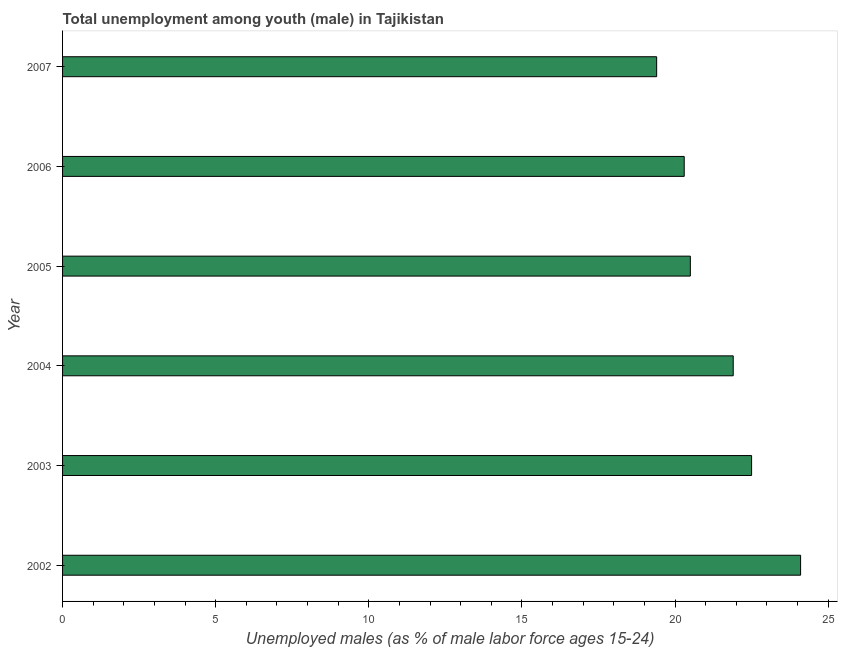Does the graph contain any zero values?
Your response must be concise. No. Does the graph contain grids?
Make the answer very short. No. What is the title of the graph?
Your answer should be very brief. Total unemployment among youth (male) in Tajikistan. What is the label or title of the X-axis?
Ensure brevity in your answer.  Unemployed males (as % of male labor force ages 15-24). What is the unemployed male youth population in 2004?
Ensure brevity in your answer.  21.9. Across all years, what is the maximum unemployed male youth population?
Offer a very short reply. 24.1. Across all years, what is the minimum unemployed male youth population?
Make the answer very short. 19.4. In which year was the unemployed male youth population minimum?
Your answer should be very brief. 2007. What is the sum of the unemployed male youth population?
Make the answer very short. 128.7. What is the difference between the unemployed male youth population in 2002 and 2003?
Offer a very short reply. 1.6. What is the average unemployed male youth population per year?
Make the answer very short. 21.45. What is the median unemployed male youth population?
Provide a succinct answer. 21.2. In how many years, is the unemployed male youth population greater than 14 %?
Your answer should be very brief. 6. What is the ratio of the unemployed male youth population in 2003 to that in 2006?
Keep it short and to the point. 1.11. Is the sum of the unemployed male youth population in 2002 and 2004 greater than the maximum unemployed male youth population across all years?
Offer a very short reply. Yes. What is the difference between the highest and the lowest unemployed male youth population?
Your response must be concise. 4.7. How many years are there in the graph?
Ensure brevity in your answer.  6. Are the values on the major ticks of X-axis written in scientific E-notation?
Your response must be concise. No. What is the Unemployed males (as % of male labor force ages 15-24) of 2002?
Your answer should be very brief. 24.1. What is the Unemployed males (as % of male labor force ages 15-24) of 2003?
Ensure brevity in your answer.  22.5. What is the Unemployed males (as % of male labor force ages 15-24) in 2004?
Your answer should be very brief. 21.9. What is the Unemployed males (as % of male labor force ages 15-24) in 2005?
Your response must be concise. 20.5. What is the Unemployed males (as % of male labor force ages 15-24) of 2006?
Keep it short and to the point. 20.3. What is the Unemployed males (as % of male labor force ages 15-24) of 2007?
Your response must be concise. 19.4. What is the difference between the Unemployed males (as % of male labor force ages 15-24) in 2002 and 2003?
Offer a very short reply. 1.6. What is the difference between the Unemployed males (as % of male labor force ages 15-24) in 2002 and 2005?
Keep it short and to the point. 3.6. What is the difference between the Unemployed males (as % of male labor force ages 15-24) in 2004 and 2005?
Your answer should be compact. 1.4. What is the difference between the Unemployed males (as % of male labor force ages 15-24) in 2004 and 2006?
Offer a terse response. 1.6. What is the difference between the Unemployed males (as % of male labor force ages 15-24) in 2005 and 2007?
Ensure brevity in your answer.  1.1. What is the difference between the Unemployed males (as % of male labor force ages 15-24) in 2006 and 2007?
Keep it short and to the point. 0.9. What is the ratio of the Unemployed males (as % of male labor force ages 15-24) in 2002 to that in 2003?
Offer a terse response. 1.07. What is the ratio of the Unemployed males (as % of male labor force ages 15-24) in 2002 to that in 2004?
Your answer should be compact. 1.1. What is the ratio of the Unemployed males (as % of male labor force ages 15-24) in 2002 to that in 2005?
Your response must be concise. 1.18. What is the ratio of the Unemployed males (as % of male labor force ages 15-24) in 2002 to that in 2006?
Ensure brevity in your answer.  1.19. What is the ratio of the Unemployed males (as % of male labor force ages 15-24) in 2002 to that in 2007?
Your answer should be very brief. 1.24. What is the ratio of the Unemployed males (as % of male labor force ages 15-24) in 2003 to that in 2004?
Make the answer very short. 1.03. What is the ratio of the Unemployed males (as % of male labor force ages 15-24) in 2003 to that in 2005?
Your response must be concise. 1.1. What is the ratio of the Unemployed males (as % of male labor force ages 15-24) in 2003 to that in 2006?
Your response must be concise. 1.11. What is the ratio of the Unemployed males (as % of male labor force ages 15-24) in 2003 to that in 2007?
Ensure brevity in your answer.  1.16. What is the ratio of the Unemployed males (as % of male labor force ages 15-24) in 2004 to that in 2005?
Your response must be concise. 1.07. What is the ratio of the Unemployed males (as % of male labor force ages 15-24) in 2004 to that in 2006?
Offer a terse response. 1.08. What is the ratio of the Unemployed males (as % of male labor force ages 15-24) in 2004 to that in 2007?
Offer a terse response. 1.13. What is the ratio of the Unemployed males (as % of male labor force ages 15-24) in 2005 to that in 2006?
Your answer should be compact. 1.01. What is the ratio of the Unemployed males (as % of male labor force ages 15-24) in 2005 to that in 2007?
Give a very brief answer. 1.06. What is the ratio of the Unemployed males (as % of male labor force ages 15-24) in 2006 to that in 2007?
Offer a very short reply. 1.05. 